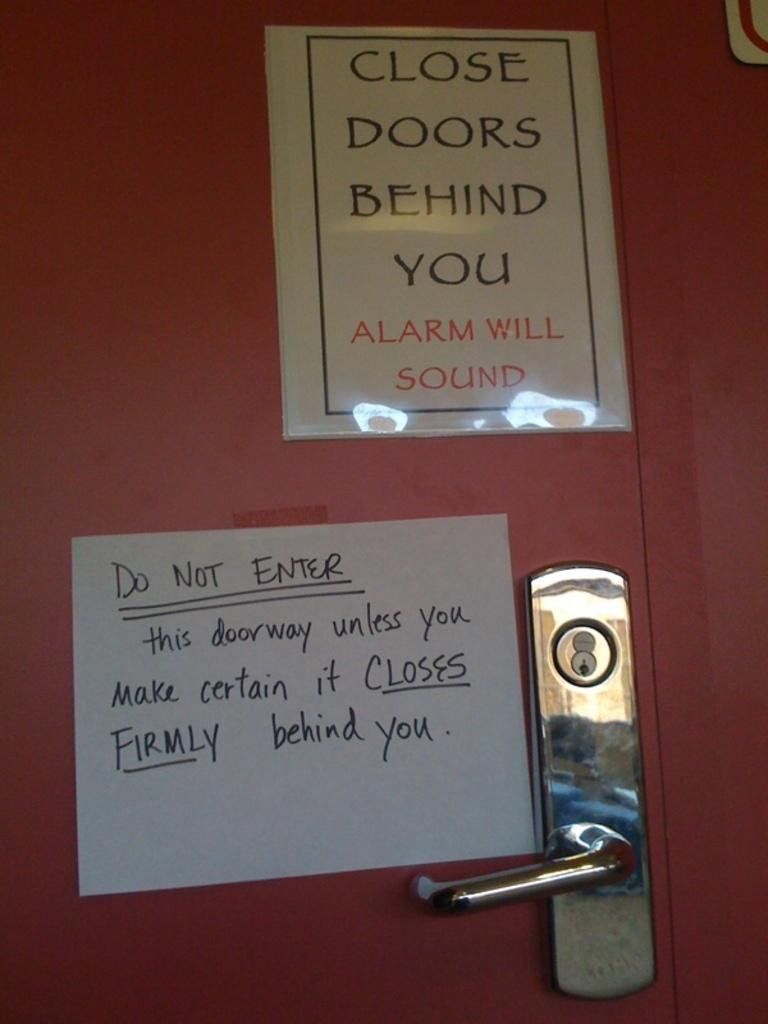<image>
Share a concise interpretation of the image provided. A couple of signs stating the importance of the door being closed. 